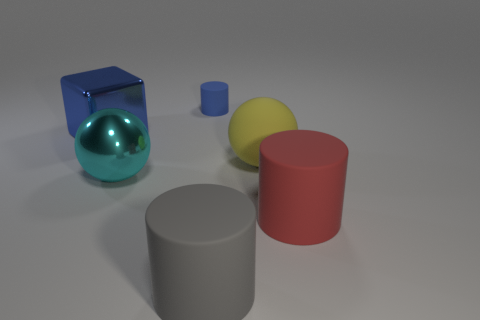Is there anything else that is the same size as the blue cylinder?
Ensure brevity in your answer.  No. There is a metallic block; does it have the same size as the cylinder that is left of the gray rubber cylinder?
Your answer should be compact. No. What number of other objects are there of the same shape as the yellow thing?
Give a very brief answer. 1. Is there a big brown ball that has the same material as the blue cube?
Make the answer very short. No. What material is the blue thing that is the same size as the red cylinder?
Your answer should be very brief. Metal. There is a large ball to the right of the cylinder behind the large shiny thing that is on the right side of the blue metal object; what is its color?
Ensure brevity in your answer.  Yellow. Does the rubber thing that is right of the big yellow object have the same shape as the gray rubber thing left of the large yellow thing?
Your answer should be compact. Yes. How many green shiny balls are there?
Make the answer very short. 0. The rubber sphere that is the same size as the red thing is what color?
Make the answer very short. Yellow. Are the large sphere that is on the right side of the big cyan metal object and the cylinder behind the cyan object made of the same material?
Offer a very short reply. Yes. 